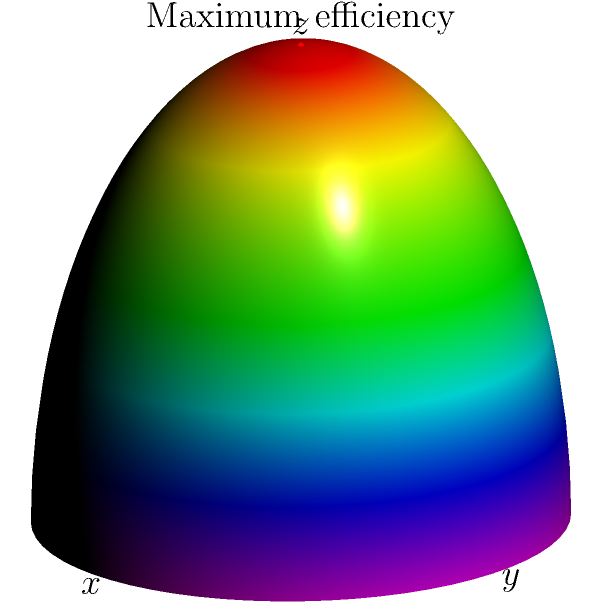Consider a solar panel array that can be adjusted in both azimuthal ($\phi$) and polar ($\theta$) angles. Using the spherical coordinate system shown in the diagram, where should the panel be oriented to achieve maximum efficiency, and what physical principle explains this orientation? To answer this question, let's follow these steps:

1. Understand the coordinate system:
   - The diagram shows a spherical coordinate system where:
     - $\theta$ is the polar angle from the z-axis (0 to $\pi$)
     - $\phi$ is the azimuthal angle in the x-y plane (0 to $2\pi$)

2. Consider the sun's position:
   - For maximum efficiency, the solar panel should be perpendicular to the sun's rays.
   - In Ireland (Northern Hemisphere), the sun is always in the southern sky.

3. Determine the optimal orientation:
   - The panel should face directly south ($\phi = \pi/2$)
   - The polar angle $\theta$ should be set to complement the sun's elevation angle.
   - At solar noon, $\theta$ would ideally be equal to the latitude of the location in Ireland.

4. Physical principle:
   - The efficiency is maximized when the panel's normal vector aligns with the sun's rays.
   - This orientation maximizes the cosine of the angle between the sun's rays and the panel's normal.

5. Optimal point in the diagram:
   - The red dot at (0,0,1) represents this optimal orientation.
   - This point corresponds to $\theta = 0$ and any value of $\phi$.

6. Practical considerations:
   - In reality, the sun's position changes throughout the day and year.
   - Advanced systems use solar tracking to continually adjust the panel's orientation.

The principle governing this orientation is the cosine effect in solar energy capture, which states that the energy received by a surface is proportional to the cosine of the angle between the surface normal and the incident light rays.
Answer: $\theta = 0$, $\phi$ = any value; aligns panel normal with sun's rays (cosine effect) 